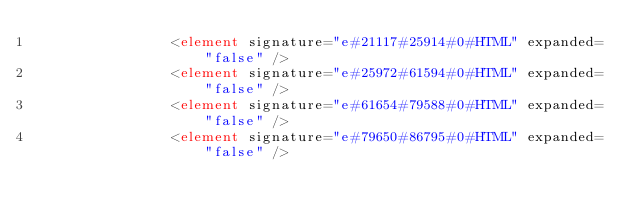Convert code to text. <code><loc_0><loc_0><loc_500><loc_500><_XML_>                <element signature="e#21117#25914#0#HTML" expanded="false" />
                <element signature="e#25972#61594#0#HTML" expanded="false" />
                <element signature="e#61654#79588#0#HTML" expanded="false" />
                <element signature="e#79650#86795#0#HTML" expanded="false" /></code> 